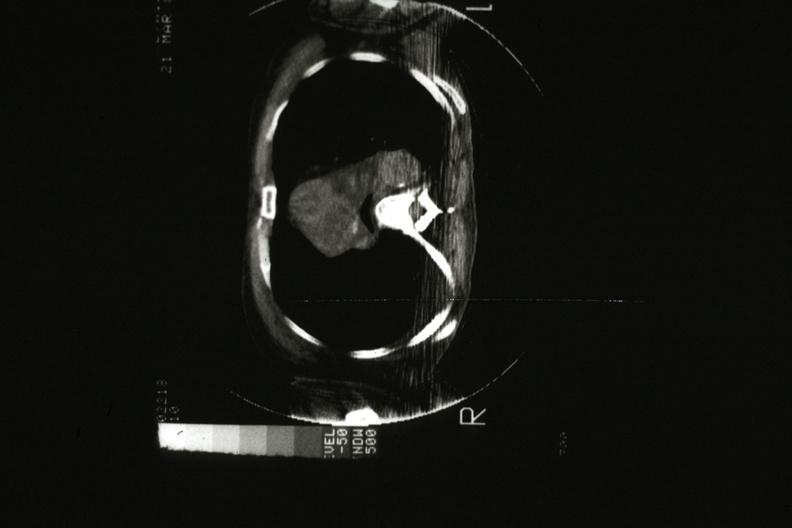what is present?
Answer the question using a single word or phrase. Hematologic 